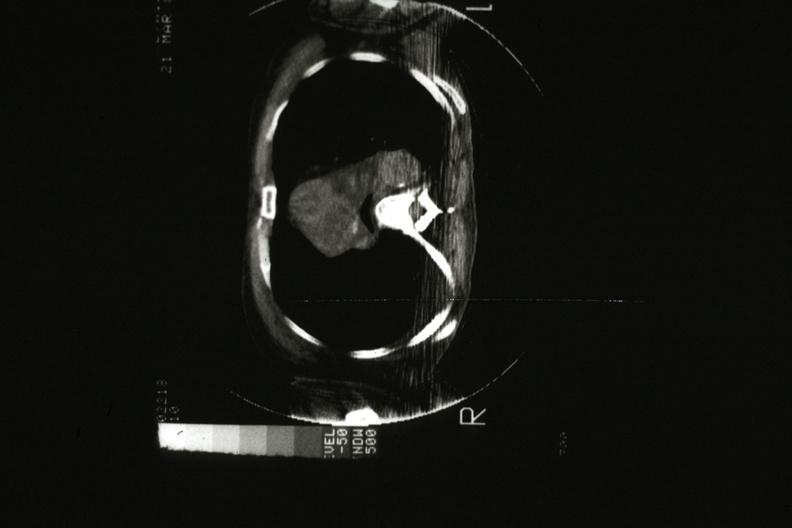what is present?
Answer the question using a single word or phrase. Hematologic 